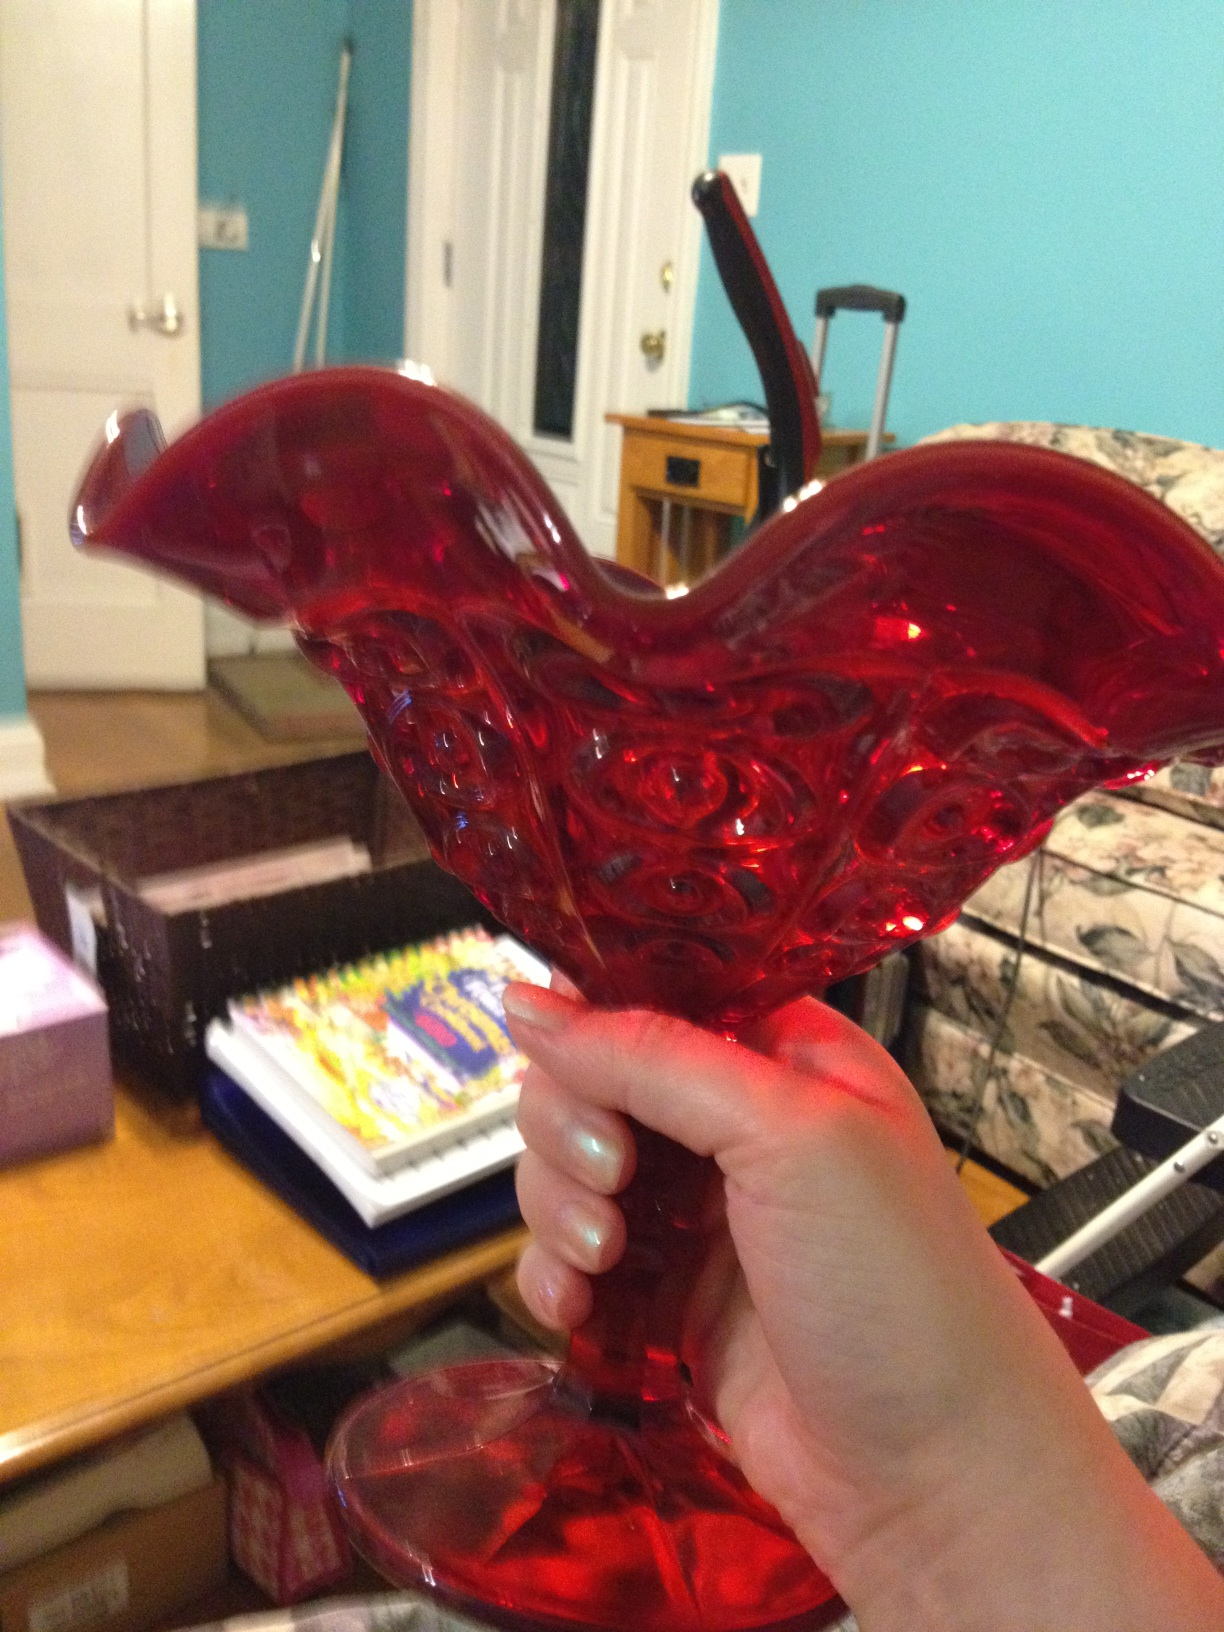Describe an emotional story involving this vase. Once, this vase held a special place in Clara's heart. It was a gift from her grandmother, given on her wedding day. The vase, vibrant and elegant, symbolized the love and strength her grandmother had taught her. As years passed, it remained a centerpiece in Clara's home, witnessing countless family gatherings, celebrations, and quiet moments. When her grandmother passed away, Clara filled the vase with her favorite flowers every year on her grandmother's birthday, keeping her memory alive through each bloom. 